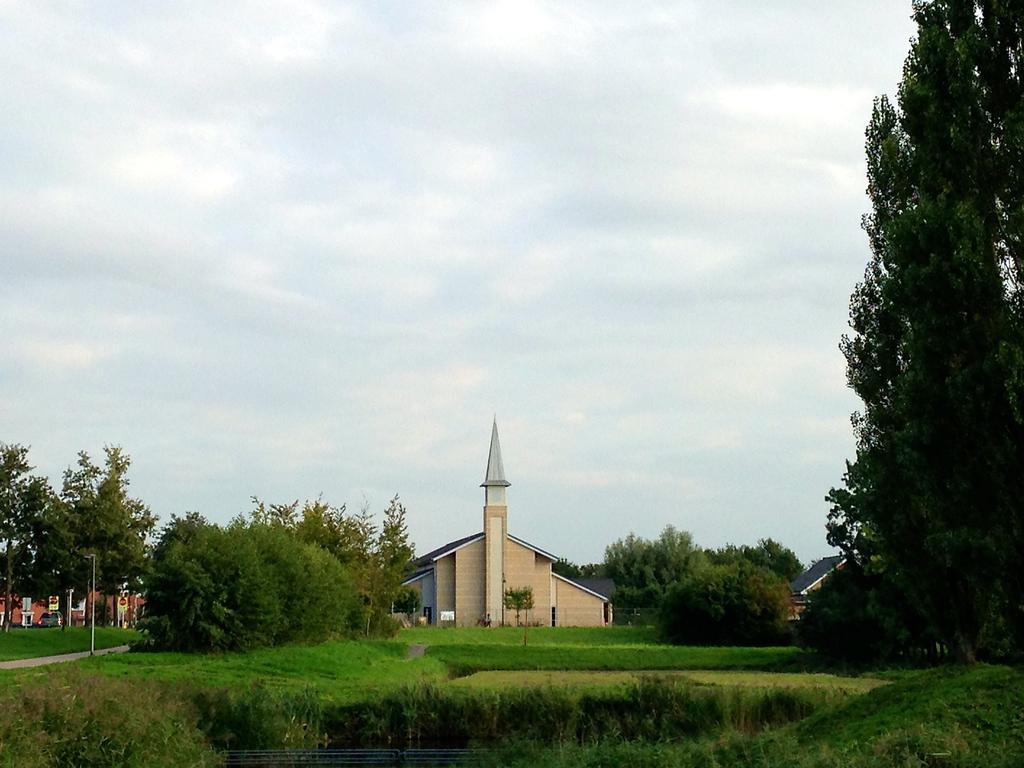Describe this image in one or two sentences. In the middle there is a house, these are the green trees in this image. At the top it is the cloudy sky. 